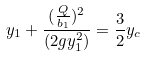<formula> <loc_0><loc_0><loc_500><loc_500>y _ { 1 } + \frac { ( \frac { Q } { b _ { 1 } } ) ^ { 2 } } { ( 2 g y _ { 1 } ^ { 2 } ) } = \frac { 3 } { 2 } y _ { c }</formula> 